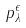Convert formula to latex. <formula><loc_0><loc_0><loc_500><loc_500>p _ { \lambda } ^ { \epsilon }</formula> 